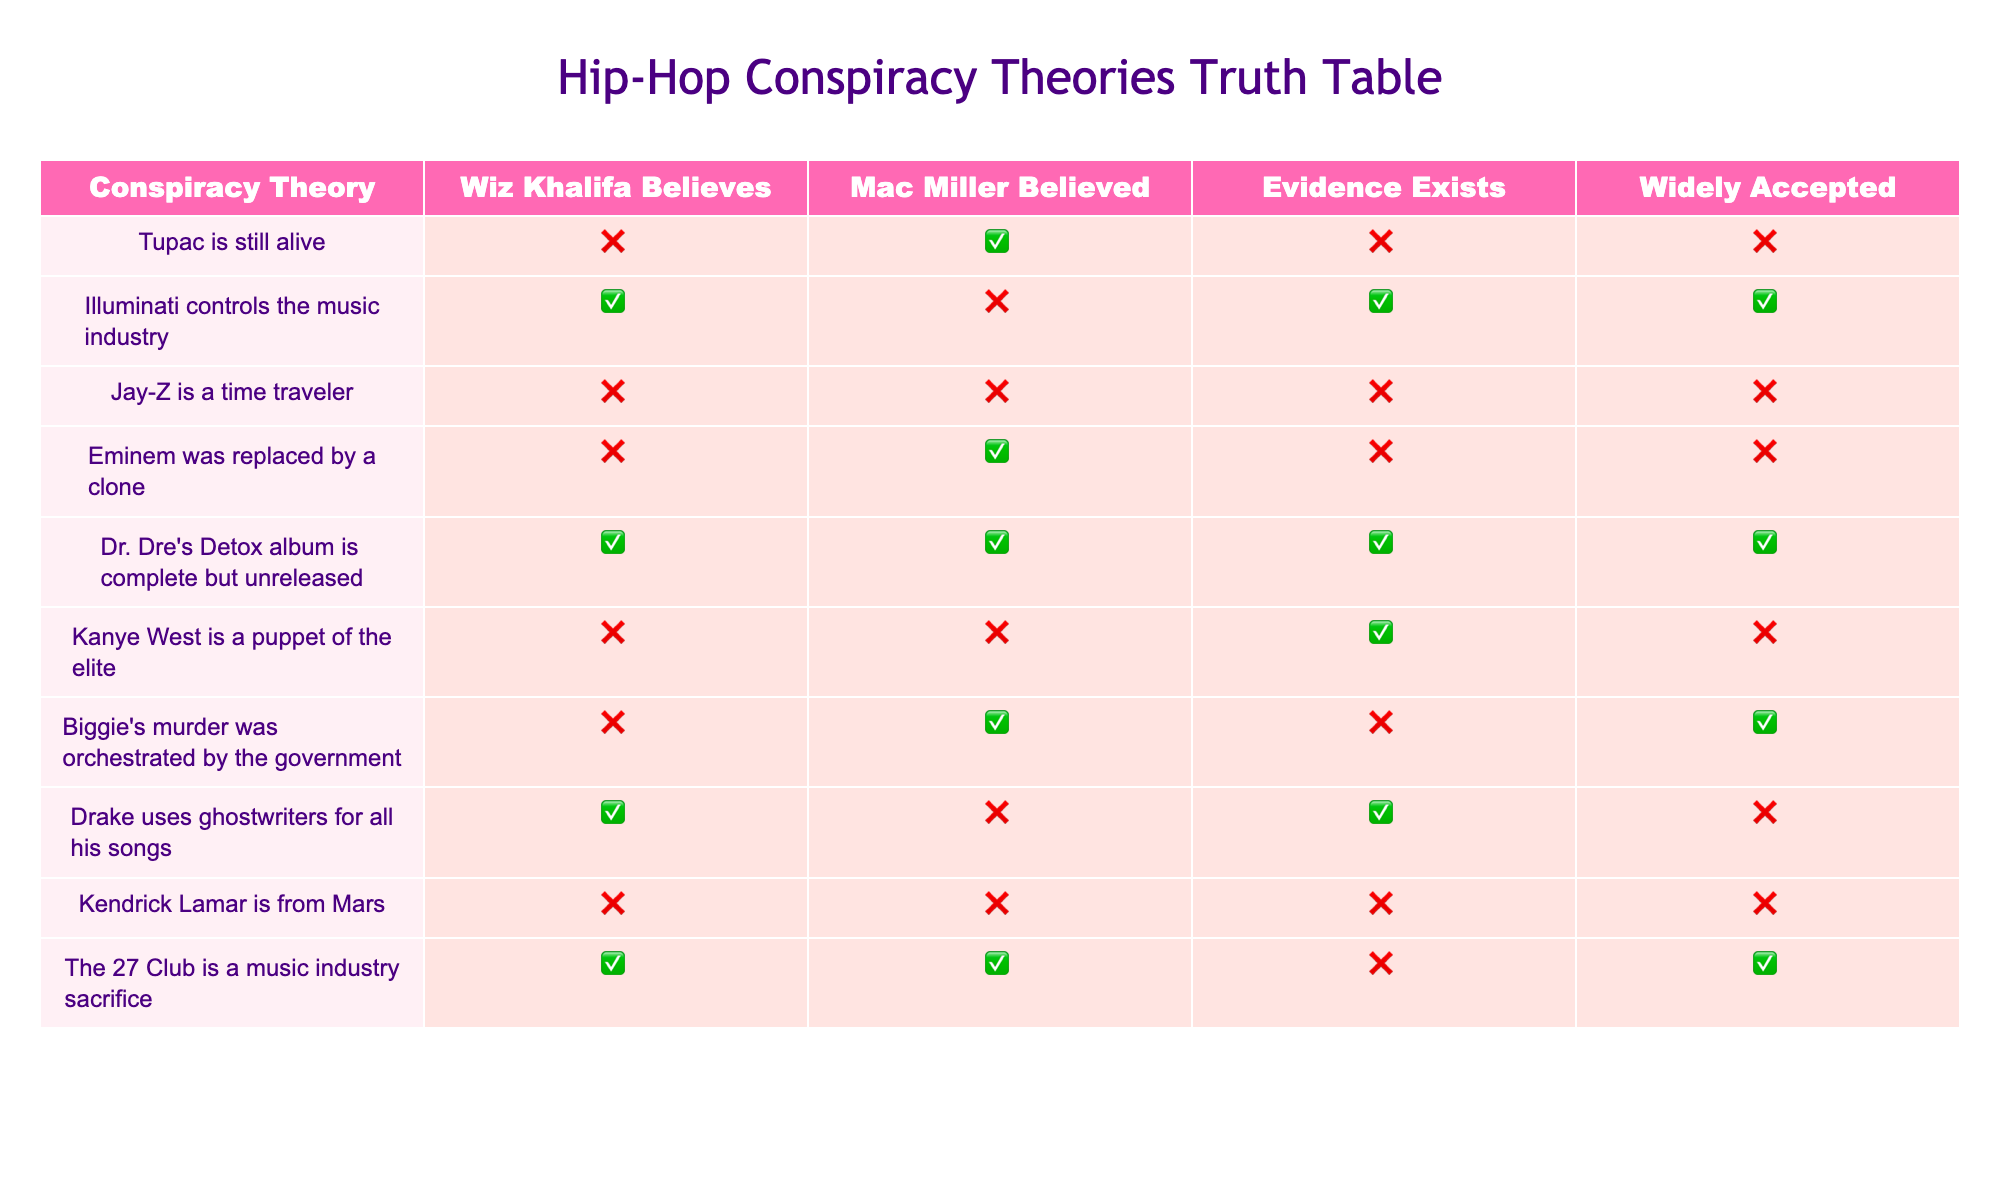What conspiracy theory does Wiz Khalifa believe in? In the table, under the column "Wiz Khalifa Believes," we look for any entry marked as true. The only entry that marks true is "Illuminati controls the music industry."
Answer: Illuminati controls the music industry How many conspiracy theories does Mac Miller believe in? We count the instances where the column "Mac Miller Believed" is true. There are four instances marked true: "Tupac is still alive," "Eminem was replaced by a clone," "Biggie's murder was orchestrated by the government," and "The 27 Club is a music industry sacrifice."
Answer: Four Is there evidence for the claim that Kanye West is a puppet of the elite? In the column "Evidence Exists," we find the entry corresponding to "Kanye West is a puppet of the elite." It is marked as false. This means there is no evidence supporting that claim.
Answer: No Which conspiracy theory is widely accepted but has no supporting evidence? We look for entries under "Widely Accepted" marked as true, and then check if "Evidence Exists" is marked as false. The only entry that fits this criterion is "Drake uses ghostwriters for all his songs."
Answer: Drake uses ghostwriters for all his songs How many conspiracy theories are attributed to both Wiz Khalifa and Mac Miller? We need to identify theories where both "Wiz Khalifa Believes" and "Mac Miller Believed" are true. The table shows that only one such theory exists: "Dr. Dre's Detox album is complete but unreleased."
Answer: One Which conspiracy theory has the most widespread acceptance? To find this, we can check the "Widely Accepted" column for theories that are marked true. The theory "Dr. Dre's Detox album is complete but unreleased" is present and is the only one that has the maximum level of acceptance indicated by being true.
Answer: Dr. Dre's Detox album is complete but unreleased Do both Wiz Khalifa and Mac Miller believe in the same conspiracy theory? Looking at the columns for "Wiz Khalifa Believes" and "Mac Miller Believed," we find that the only conspiracy theory they both agree on is "Dr. Dre's Detox album is complete but unreleased."
Answer: Yes What percentage of conspiracy theories does Eminem get mentioned in? There are ten theories in total, and Eminem is referenced in two of them: "Eminem was replaced by a clone" and "Dr. Dre's Detox album is complete but unreleased." Therefore, the percentage is calculated by (2/10) * 100 = 20%.
Answer: 20% 